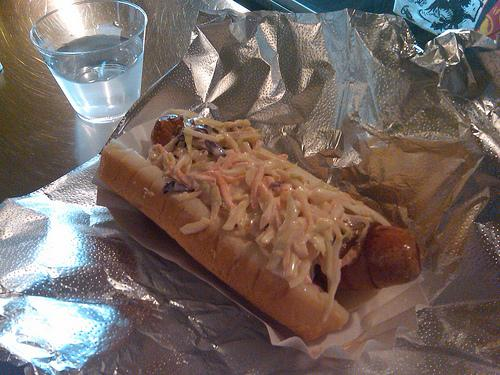Mention the main dish in the image and describe its appearance. The main dish is a hot dog on a bun, featuring cold slaw piled on top. Identify the main food element in the photo and the surface it's resting on. A hot dog on a bun is the main food element, and it's resting on silver foil. Find the two main objects in the image and explain their different states of fullness. A hot dog on a bun is topped with cold slaw, while a nearby cup is half full of water. Name two items in the image, and describe the material from which they are made. A hot dog bun made of bread and a plastic cup holding water are two items in the image. Identify what is covering the table in the photo, and describe its appearance. The table is covered in aluminum foil, which appears crumpled and shiny. Describe the beverage container in the image, its contents, and the material it is made out of. The beverage container is a small, clear plastic cup filled with water. List two objects in the image, their colors and their relationship to one another. A brown hot dog on a bun and a clear cup of water are close to each other on the table. What is on the surface of the table, and does it reflect any light? The table surface is covered in aluminum foil and reflects blue light. What is the primary food item in the image, and what is on top of it? The primary food item is a hot dog on a bun with cold slaw on top. Identify the main food item and the material it is resting on. The main food item is a hot dog on a bun, resting on a sheet of aluminum foil. 